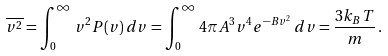<formula> <loc_0><loc_0><loc_500><loc_500>\overline { v ^ { 2 } } = \int _ { 0 } ^ { \infty } \, v ^ { 2 } P ( v ) \, d v = \int _ { 0 } ^ { \infty } \, 4 \pi A ^ { 3 } v ^ { 4 } e ^ { - B v ^ { 2 } } \, d v = \frac { 3 k _ { B } T } { m } \, .</formula> 